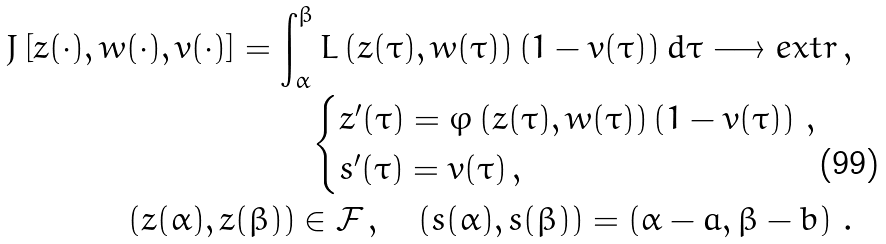Convert formula to latex. <formula><loc_0><loc_0><loc_500><loc_500>J \left [ z ( \cdot ) , w ( \cdot ) , v ( \cdot ) \right ] = \int _ { \alpha } ^ { \beta } L \left ( z ( \tau ) , w ( \tau ) \right ) \left ( 1 - v ( \tau ) \right ) d \tau \longrightarrow e x t r \, , \\ \begin{cases} z ^ { \prime } ( \tau ) = \varphi \left ( z ( \tau ) , w ( \tau ) \right ) \left ( 1 - v ( \tau ) \right ) \, , \\ s ^ { \prime } ( \tau ) = v ( \tau ) \, , \end{cases} \\ \left ( z ( \alpha ) , z ( \beta ) \right ) \in \mathcal { F } \, , \quad \left ( s ( \alpha ) , s ( \beta ) \right ) = \left ( \alpha - a , \beta - b \right ) \, .</formula> 